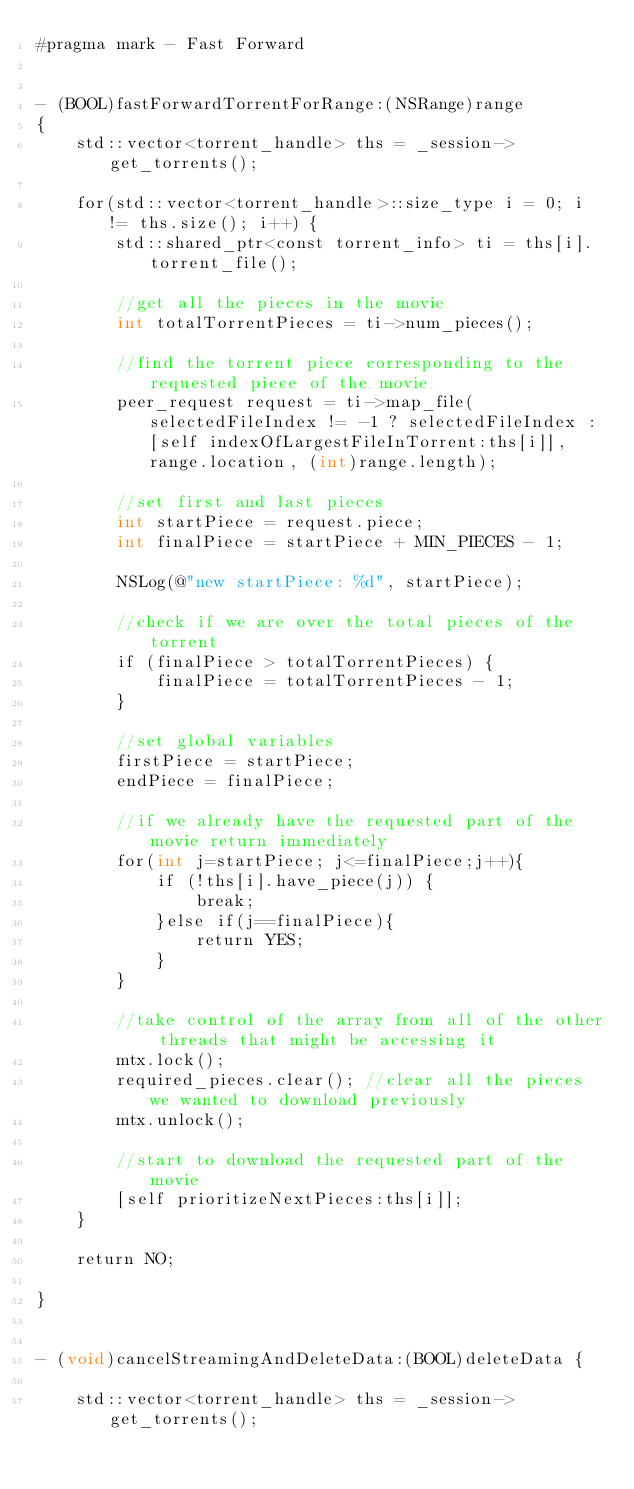<code> <loc_0><loc_0><loc_500><loc_500><_ObjectiveC_>#pragma mark - Fast Forward


- (BOOL)fastForwardTorrentForRange:(NSRange)range
{
    std::vector<torrent_handle> ths = _session->get_torrents();
    
    for(std::vector<torrent_handle>::size_type i = 0; i != ths.size(); i++) {
        std::shared_ptr<const torrent_info> ti = ths[i].torrent_file();
        
        //get all the pieces in the movie
        int totalTorrentPieces = ti->num_pieces();
        
        //find the torrent piece corresponding to the requested piece of the movie
        peer_request request = ti->map_file(selectedFileIndex != -1 ? selectedFileIndex : [self indexOfLargestFileInTorrent:ths[i]], range.location, (int)range.length);
        
        //set first and last pieces
        int startPiece = request.piece;
        int finalPiece = startPiece + MIN_PIECES - 1;
        
        NSLog(@"new startPiece: %d", startPiece);
        
        //check if we are over the total pieces of the torrent
        if (finalPiece > totalTorrentPieces) {
            finalPiece = totalTorrentPieces - 1;
        }
        
        //set global variables
        firstPiece = startPiece;
        endPiece = finalPiece;
        
        //if we already have the requested part of the movie return immediately
        for(int j=startPiece; j<=finalPiece;j++){
            if (!ths[i].have_piece(j)) {
                break;
            }else if(j==finalPiece){
                return YES;
            }
        }
        
        //take control of the array from all of the other threads that might be accessing it
        mtx.lock();
        required_pieces.clear(); //clear all the pieces we wanted to download previously
        mtx.unlock();
        
        //start to download the requested part of the movie
        [self prioritizeNextPieces:ths[i]];
    }
    
    return NO;
    
}


- (void)cancelStreamingAndDeleteData:(BOOL)deleteData {
    
    std::vector<torrent_handle> ths = _session->get_torrents();</code> 